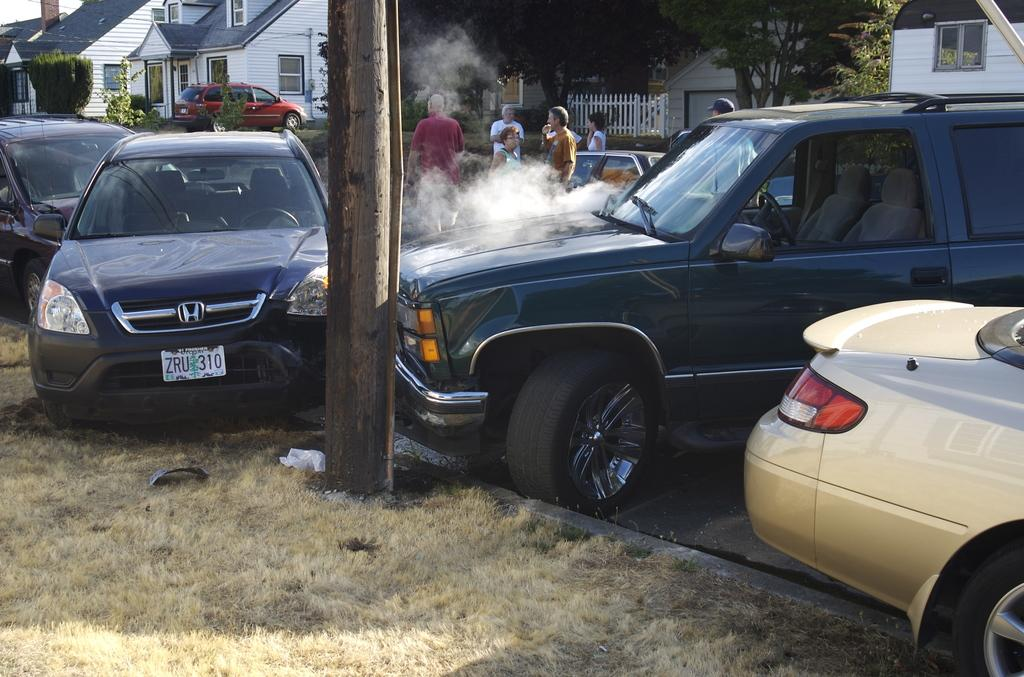What can be seen on the road in the image? There are vehicles on the road in the image. What is located in the center of the image? There is a pole in the center of the image. What type of structures can be seen in the background of the image? Houses are visible in the background of the image. What else can be seen in the background of the image? Trees, persons, plants, and the sky are visible in the background of the image. What type of whistle can be heard during the class in the image? There is no class or whistle present in the image. What type of loss is depicted in the image? There is no loss depicted in the image; it features vehicles on the road, a pole, houses, trees, persons, plants, and the sky. 